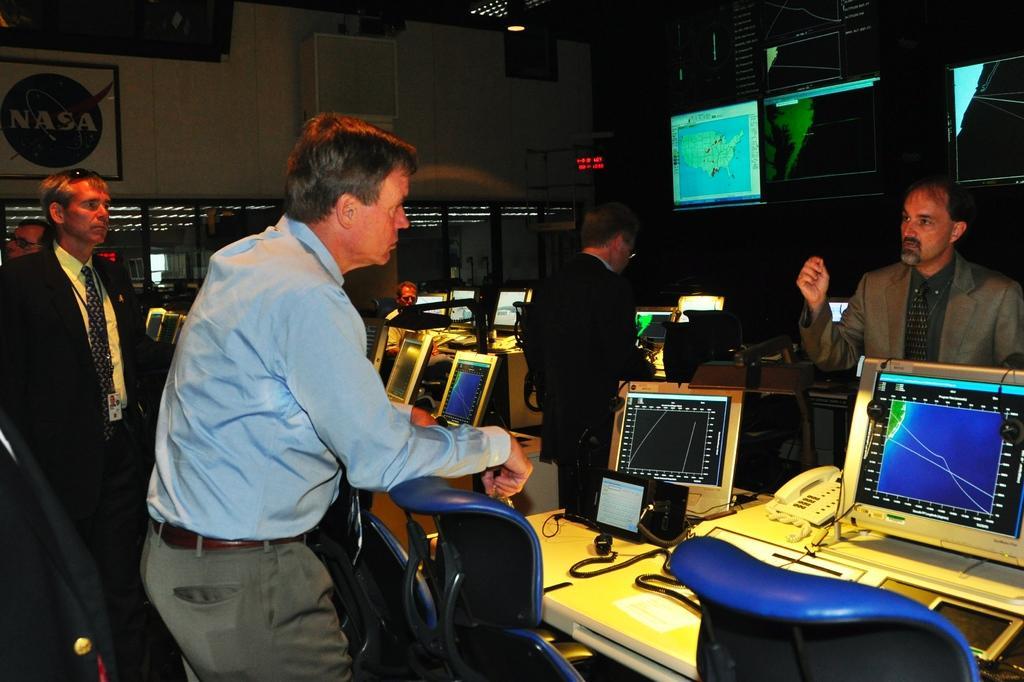Could you give a brief overview of what you see in this image? In the image there are few men standing on either side of table with laptops,telephones on it in front of chairs and over the back there are screens on the wall, on the left side there is a photograph on the wall. 